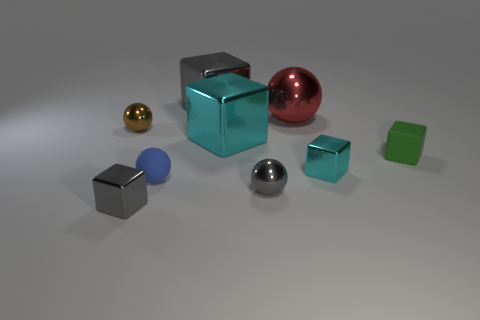Is the rubber sphere the same color as the large metal sphere? no 